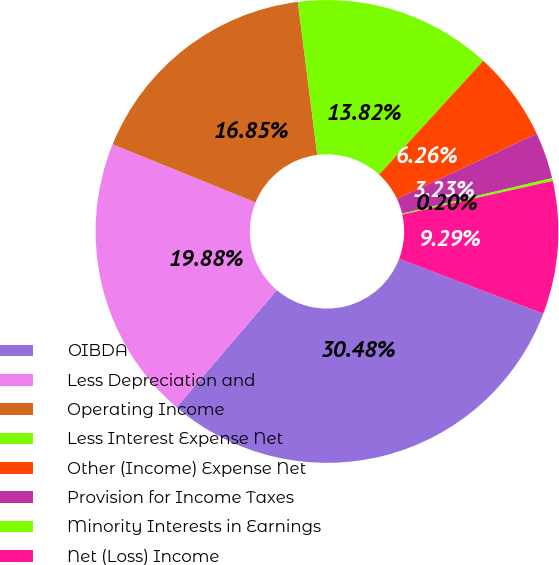<chart> <loc_0><loc_0><loc_500><loc_500><pie_chart><fcel>OIBDA<fcel>Less Depreciation and<fcel>Operating Income<fcel>Less Interest Expense Net<fcel>Other (Income) Expense Net<fcel>Provision for Income Taxes<fcel>Minority Interests in Earnings<fcel>Net (Loss) Income<nl><fcel>30.49%<fcel>19.88%<fcel>16.85%<fcel>13.82%<fcel>6.26%<fcel>3.23%<fcel>0.2%<fcel>9.29%<nl></chart> 